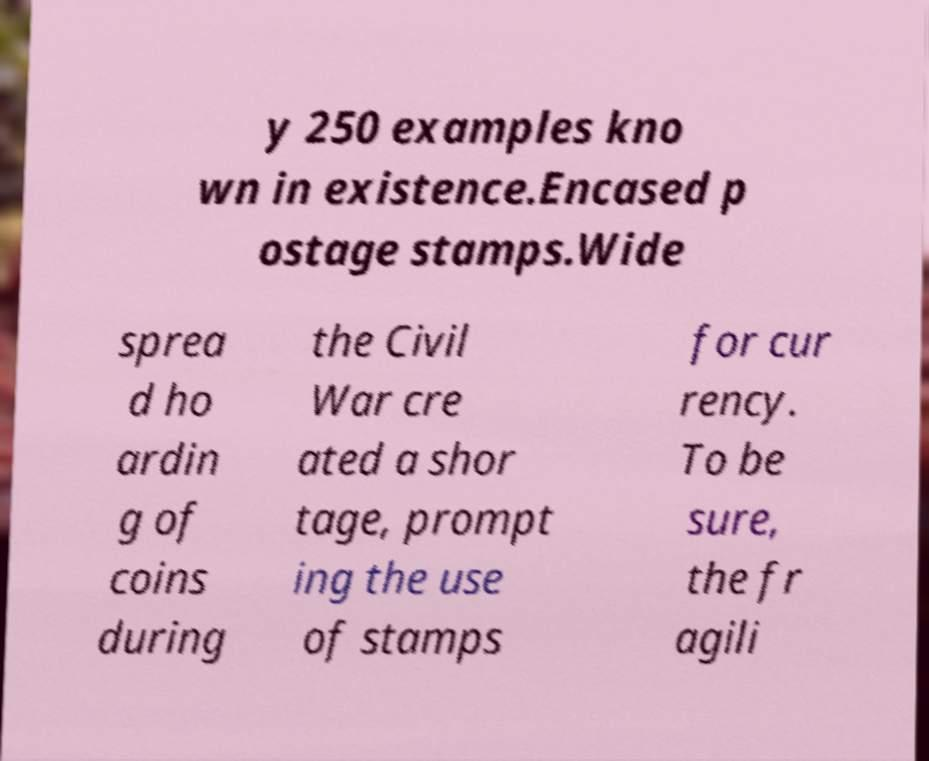For documentation purposes, I need the text within this image transcribed. Could you provide that? y 250 examples kno wn in existence.Encased p ostage stamps.Wide sprea d ho ardin g of coins during the Civil War cre ated a shor tage, prompt ing the use of stamps for cur rency. To be sure, the fr agili 